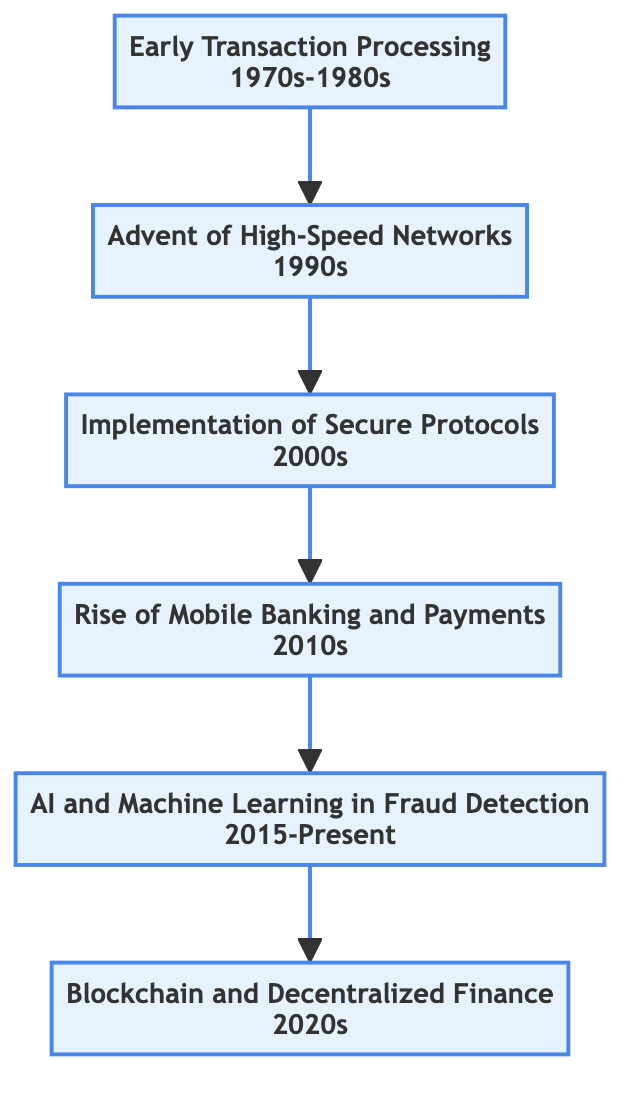What is the title of the first stage? The first stage in the diagram is labeled as "Early Transaction Processing" which introduces basic electronic transaction systems like ATMs and EFT.
Answer: Early Transaction Processing In which decade did the "Advent of High-Speed Networks" occur? The "Advent of High-Speed Networks" is stated to take place in the 1990s, according to the time period listed under that stage.
Answer: 1990s What impact is noted for the implementation of secure protocols? The diagram describes the impact of implementing secure protocols as "Enhanced security, reducing risks of data breaches and fraud."
Answer: Enhanced security, reducing risks of data breaches and fraud Which technology is associated with the fifth stage? The fifth stage titled "AI and Machine Learning in Fraud Detection" mentions the utilization of artificial intelligence and machine learning algorithms, indicating its association.
Answer: AI and Machine Learning What is the relationship between "Rise of Mobile Banking and Payments" and "Blockchain and Decentralized Finance"? "Rise of Mobile Banking and Payments" is a precursor to "Blockchain and Decentralized Finance," as they are sequential stages in the diagram, with the latter following the former.
Answer: Sequential relationship How many stages are there in total? The diagram indicates six distinct stages, each with its own title and description, from early transaction processing to decentralized finance.
Answer: Six stages What technological advancement does the fourth stage focus on? The fourth stage focuses on mobile technology, notably the growth of mobile banking apps and digital payment solutions in the 2010s.
Answer: Mobile technology What trend is highlighted in the "Blockchain and Decentralized Finance" stage? The trend highlighted in this stage is the emergence of blockchain technology, promoting security, efficiency, and transparency in financial transactions.
Answer: Emergence of blockchain technology What time period does the evolution from "Implementation of Secure Protocols" to "AI and Machine Learning in Fraud Detection" cover? The evolution from "Implementation of Secure Protocols" in the 2000s to "AI and Machine Learning in Fraud Detection" covers the period from the 2000s through to the present (2015-Present).
Answer: 2000s to 2015-Present 